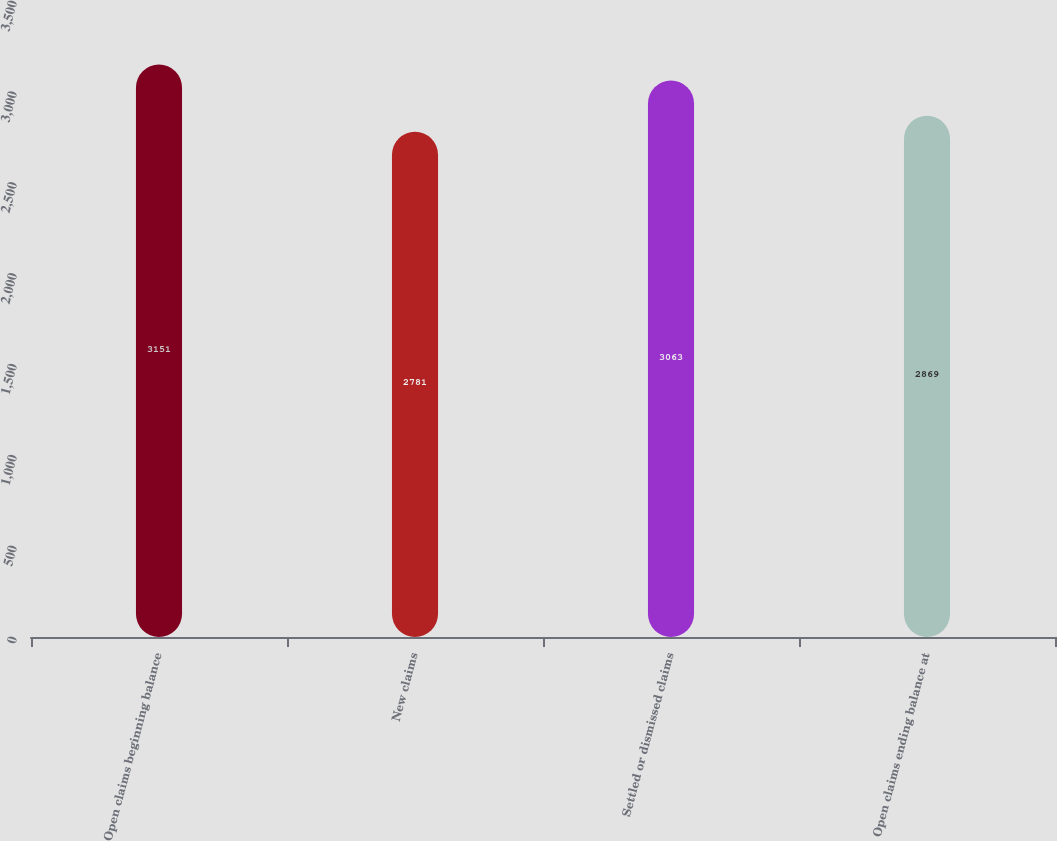Convert chart to OTSL. <chart><loc_0><loc_0><loc_500><loc_500><bar_chart><fcel>Open claims beginning balance<fcel>New claims<fcel>Settled or dismissed claims<fcel>Open claims ending balance at<nl><fcel>3151<fcel>2781<fcel>3063<fcel>2869<nl></chart> 